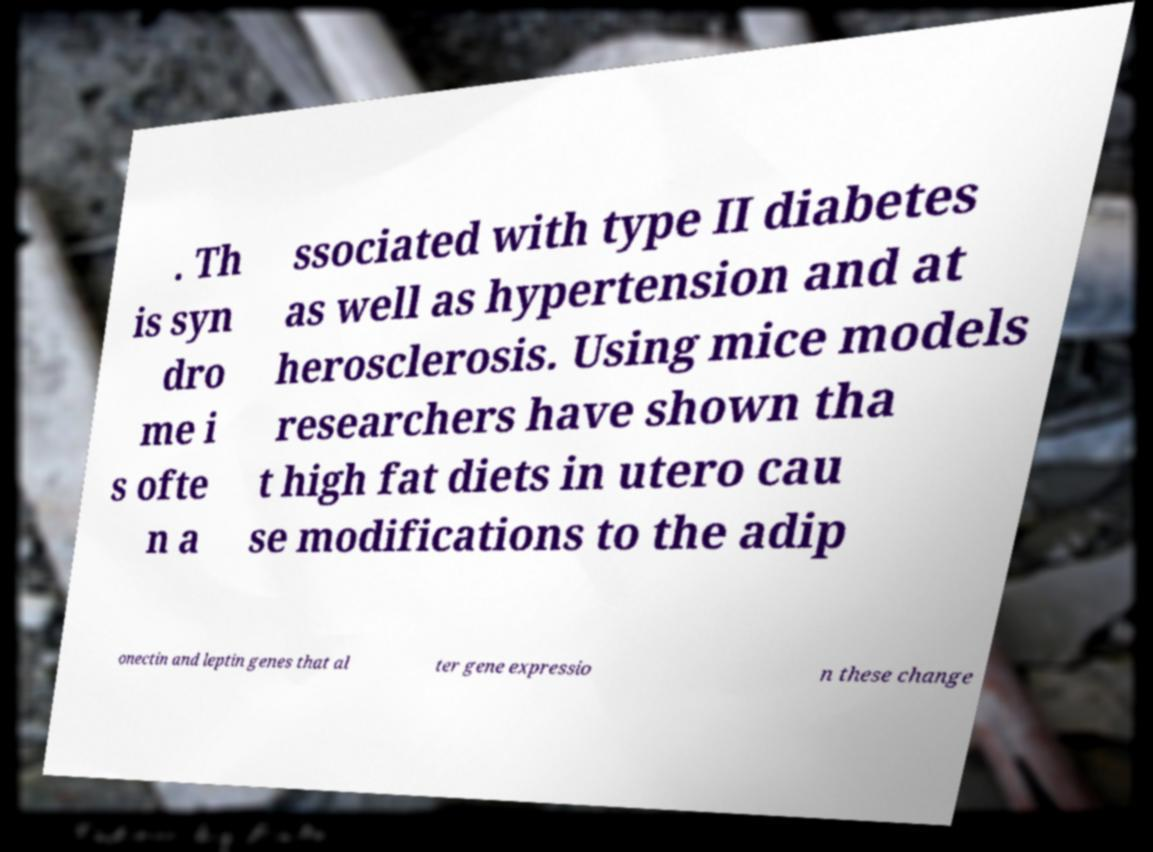Please identify and transcribe the text found in this image. . Th is syn dro me i s ofte n a ssociated with type II diabetes as well as hypertension and at herosclerosis. Using mice models researchers have shown tha t high fat diets in utero cau se modifications to the adip onectin and leptin genes that al ter gene expressio n these change 